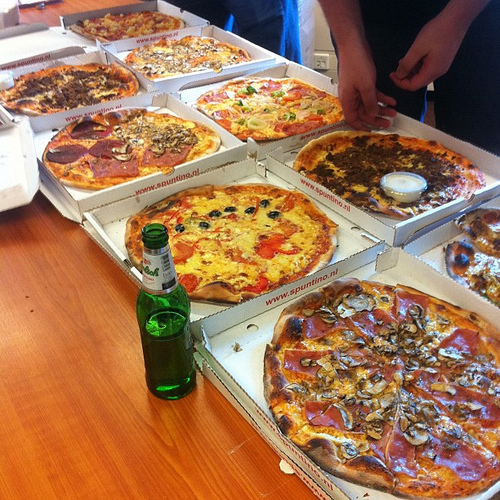What is the name of the vegetable to the right of the sausage in the top of the image? The vegetable to the right of the sausage in the top of the image is a pepper. 